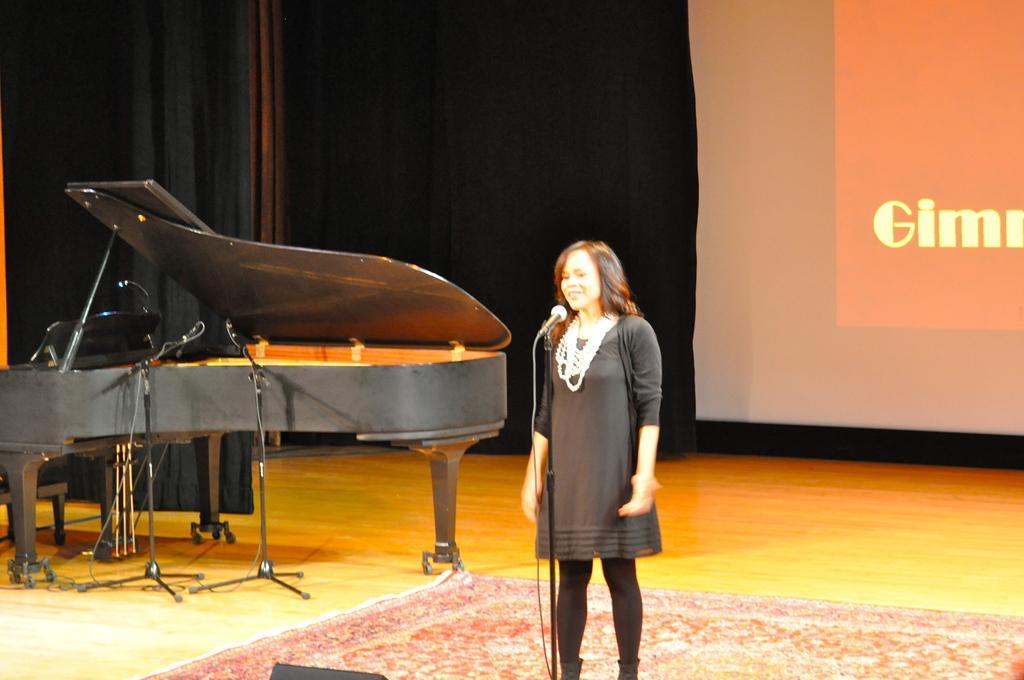Please provide a concise description of this image. This person standing. There is a microphone with stand. This is musical instrument. On the background we can see screen. This is floor. 